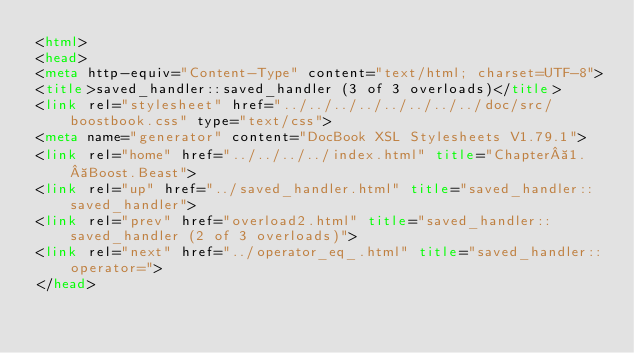Convert code to text. <code><loc_0><loc_0><loc_500><loc_500><_HTML_><html>
<head>
<meta http-equiv="Content-Type" content="text/html; charset=UTF-8">
<title>saved_handler::saved_handler (3 of 3 overloads)</title>
<link rel="stylesheet" href="../../../../../../../../doc/src/boostbook.css" type="text/css">
<meta name="generator" content="DocBook XSL Stylesheets V1.79.1">
<link rel="home" href="../../../../index.html" title="Chapter 1. Boost.Beast">
<link rel="up" href="../saved_handler.html" title="saved_handler::saved_handler">
<link rel="prev" href="overload2.html" title="saved_handler::saved_handler (2 of 3 overloads)">
<link rel="next" href="../operator_eq_.html" title="saved_handler::operator=">
</head></code> 